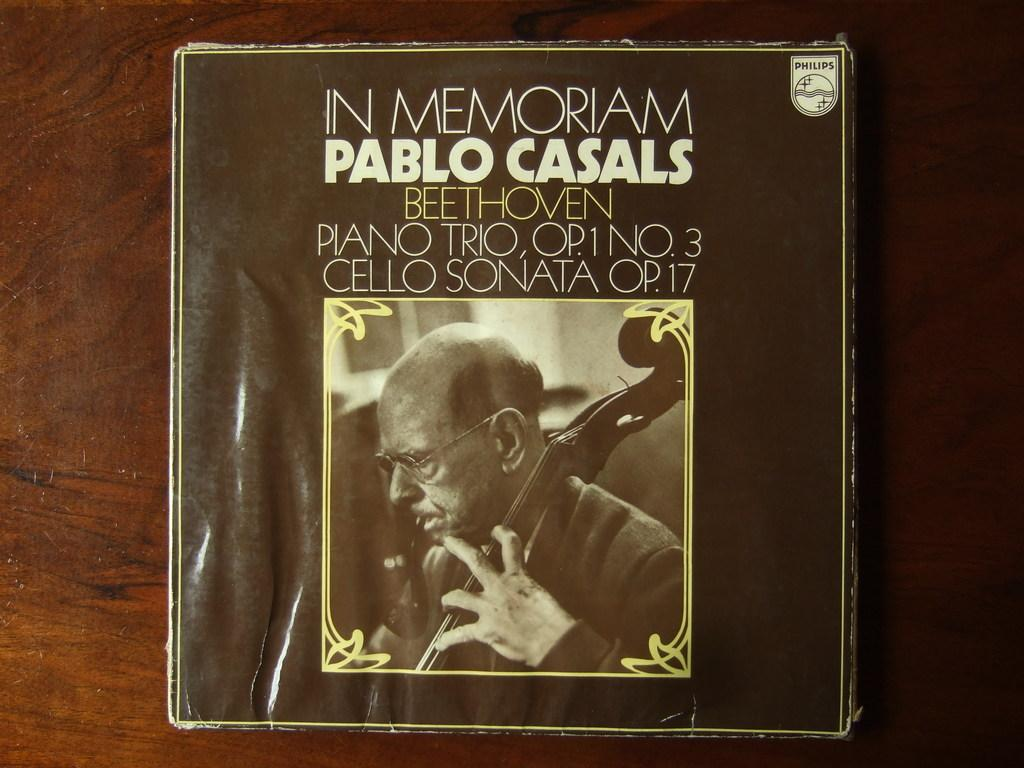<image>
Relay a brief, clear account of the picture shown. A record cover for an album that is in memory of Pablo Casals. 